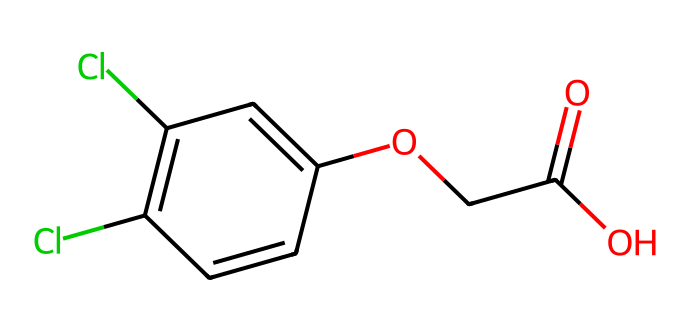What is the IUPAC name of this compound? The IUPAC name can be deduced from the SMILES representation, which indicates functional groups and substituents. The compound has a phenoxy group with a dichloro substitution and an acetic acid moiety, leading to the IUPAC name 2,4-Dichlorophenoxyacetic acid.
Answer: 2,4-Dichlorophenoxyacetic acid How many carbon atoms are present in this molecule? By analyzing the chemical structure indicated in the SMILES, one can count the carbon atoms. The aromatic ring contributes 6 carbon atoms, and the acetic acid side gives 2 additional carbon atoms, resulting in a total of 8 carbon atoms.
Answer: 8 What functional groups are present in this compound? The analysis of the SMILES reveals that the essential functional groups are the phenoxy (indicated by the phenyl ring and ether link) and the carboxylic acid (represented by the -COOH group). Both are integral to its herbicidal activity.
Answer: phenoxy and carboxylic acid How many chlorine atoms are bonded to this compound? The presence of chlorine is indicated directly in the SMILES by “Cl” at two locations, signifying the two chlorine atoms attached at the 2 and 4 positions on the phenyl ring.
Answer: 2 What is the molecular formula of this herbicide? By tallying the elements present based on the SMILES, we obtain the molecular formula: there are 8 carbon atoms, 6 hydrogen atoms, 2 chlorine atoms, and 4 oxygen atoms, resulting in the molecular formula C8H6Cl2O3.
Answer: C8H6Cl2O3 What makes this herbicide selective for broadleaf weeds? The selective nature arises from its structural similarity to natural plant growth hormones (auxins), which specifically affect broadleaf species while sparing grasses, making it effective in targeting unintended plant types.
Answer: similarity to auxins 